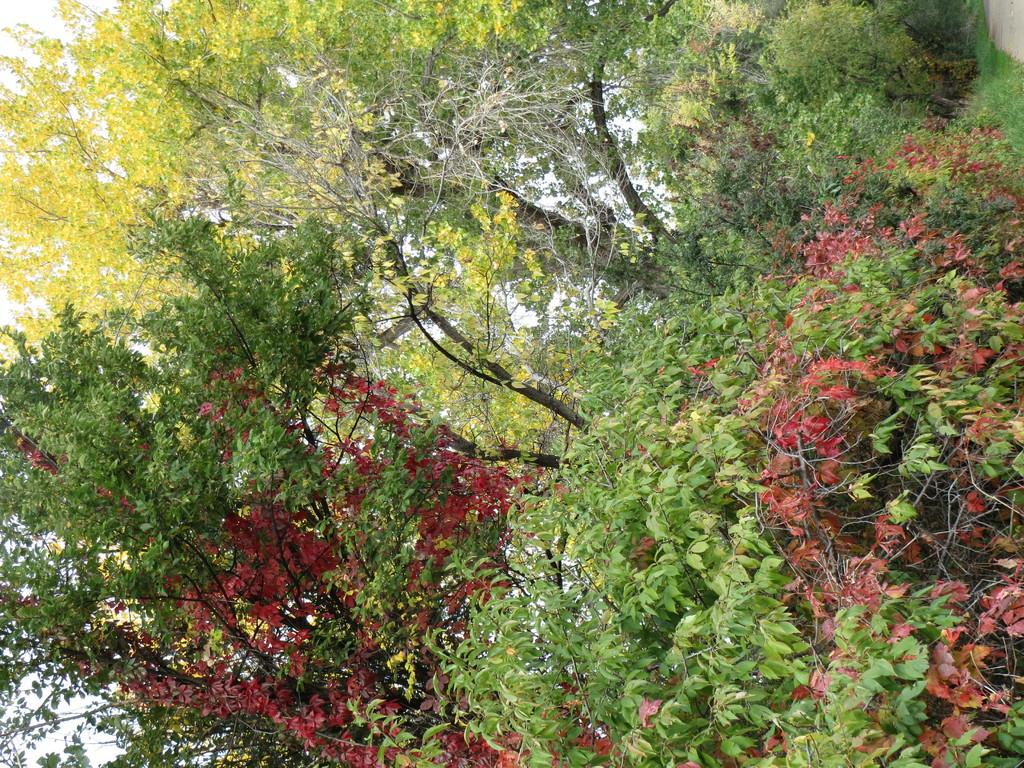What is the main feature of the image? The main feature of the image is the many trees. What can be observed about the leaves of the trees? The leaves of the trees have different colors. What else can be seen in the image besides the trees? The sky is visible in the image. What type of ink is being used to write on the trees in the image? There is no ink or writing present on the trees in the image. Which direction is the north indicated in the image? The image does not contain any elements or references to indicate a specific direction, such as north. 